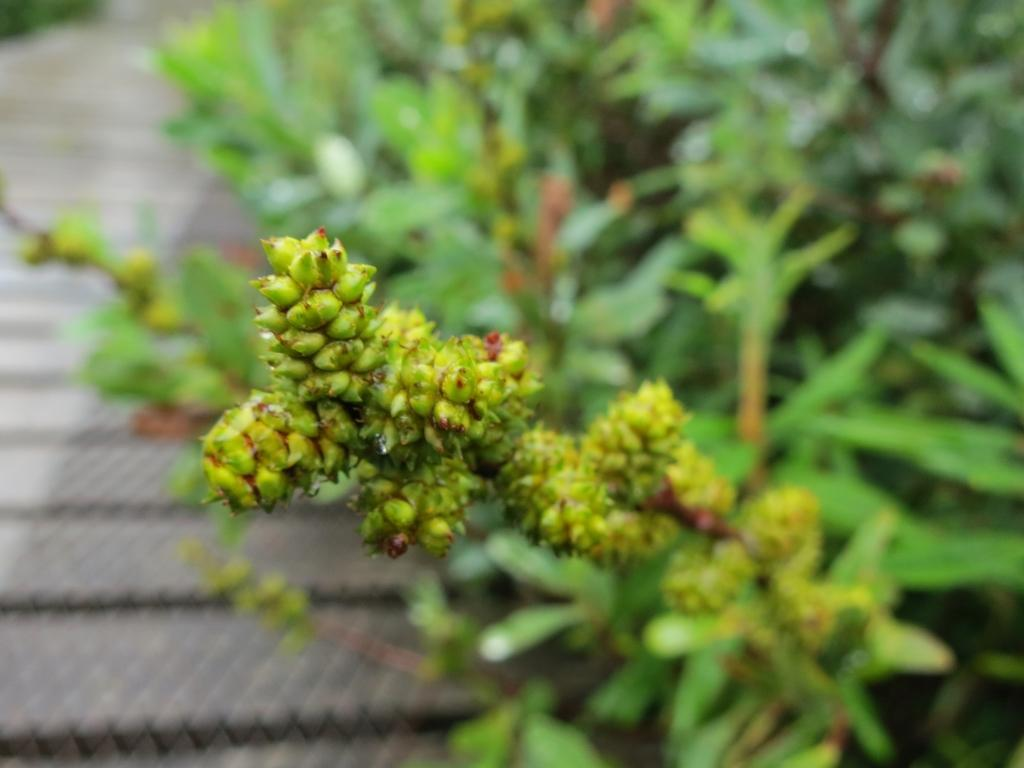What type of living organisms can be seen in the image? Plants can be seen in the image. How many frogs are sitting on the screw in the image? There are no frogs or screws present in the image; it only contains plants. 